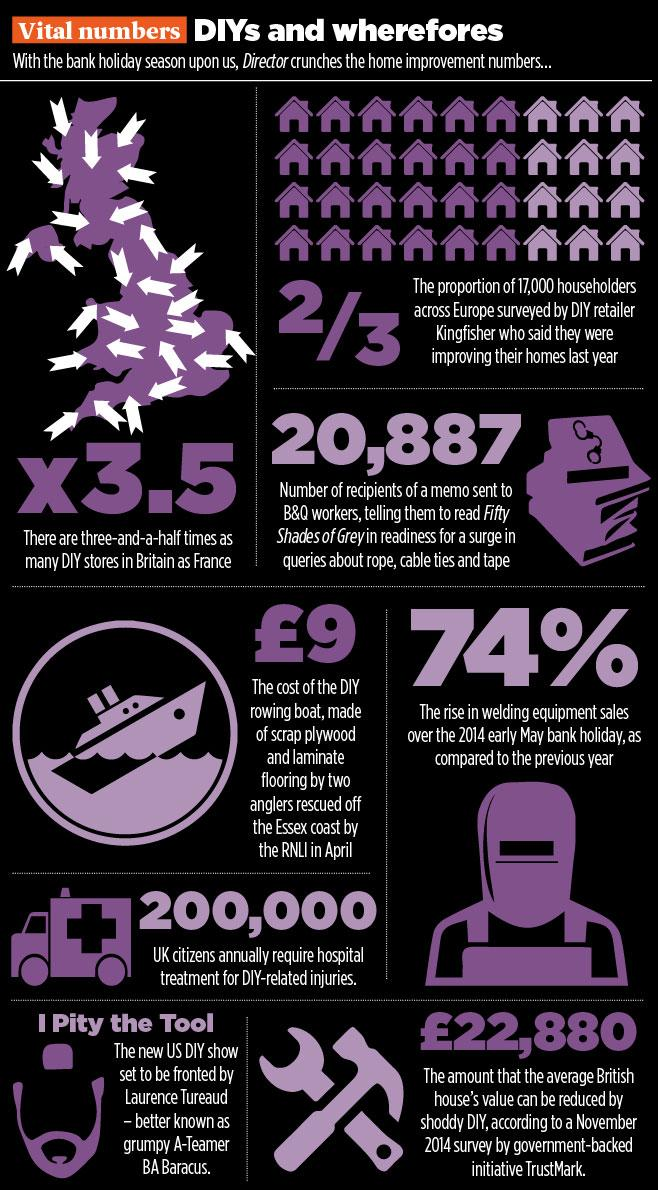Draw attention to some important aspects in this diagram. It is estimated that approximately 200,000 UK citizens require hospital treatment each year as a result of injuries sustained while engaging in do-it-yourself (DIY) activities. Sales of welding equipment during the 2014 early May bank holiday increased by 74% compared to the previous year. According to a November 2014 survey conducted by the government-backed initiative TrustMark, the average British house's value can be reduced by shoddy DIY work by an average of 22,880 pounds. 